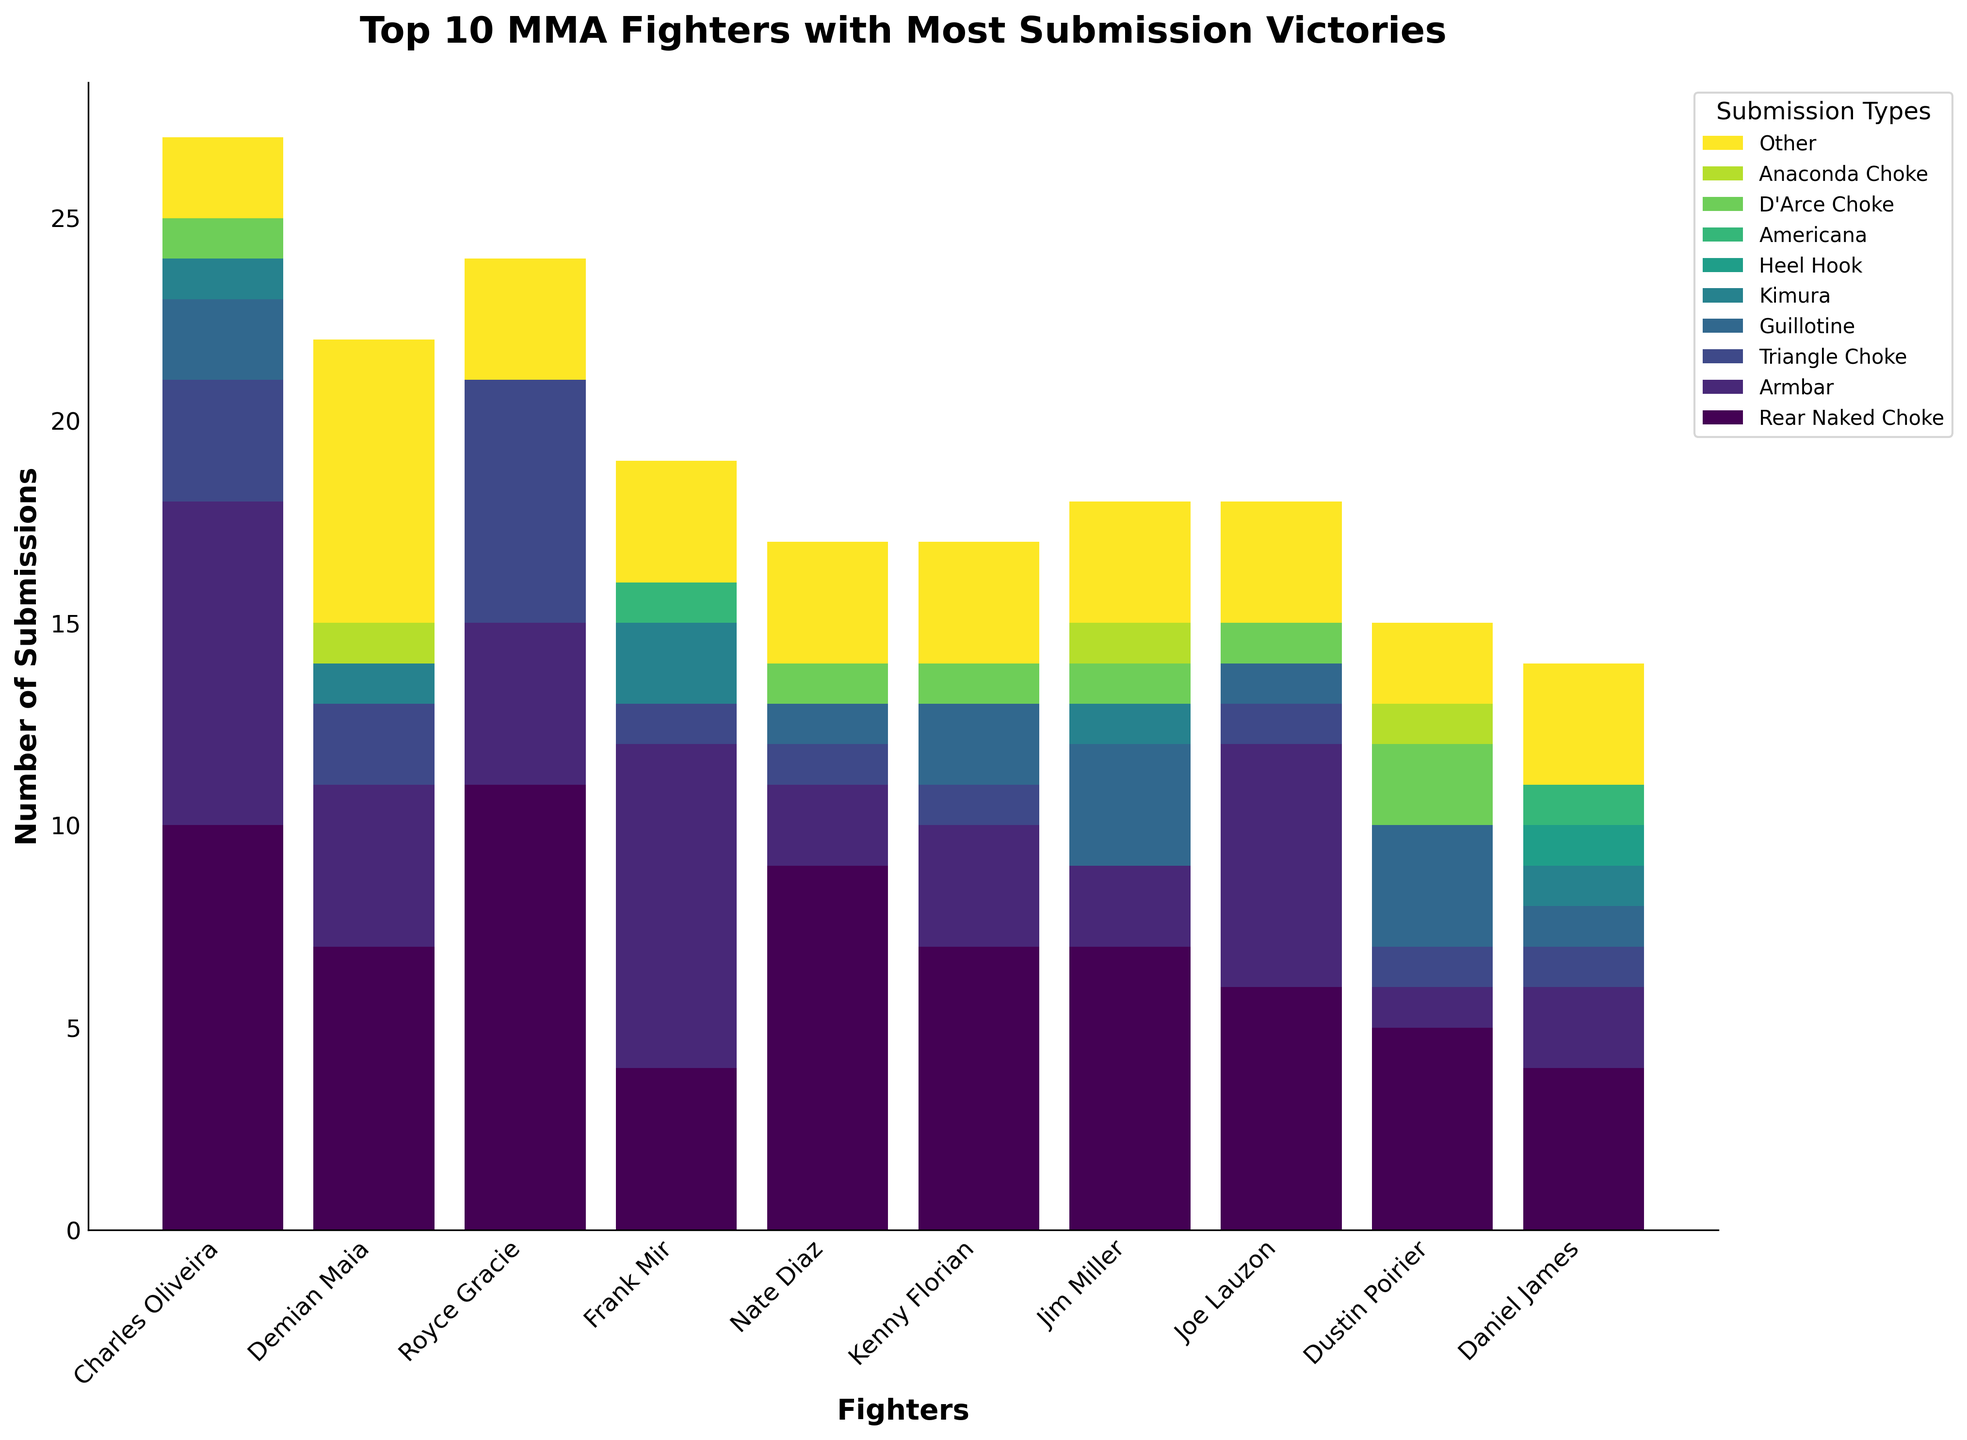Which fighter has the highest number of Rear Naked Chokes? Look for the tallest bar segment colored in the shade representing "Rear Naked Choke." Charles Oliveira's bar is the highest with 10 Rear Naked Chokes.
Answer: Charles Oliveira Who has more Armbar submissions, Frank Mir or Joe Lauzon? Compare the height of the bar segments corresponding to "Armbar" for Frank Mir and Joe Lauzon. Frank Mir has 8 Armbar submissions, and Joe Lauzon has 6.
Answer: Frank Mir How many total Guillotine submissions are there among the top 10 fighters? Add the Guillotine submission counts for all 10 fighters: 2+0+0+0+1+2+3+1+3+1=13.
Answer: 13 Who has the highest number of total submissions and how many? Sum the heights of all the bar segments for each fighter; Royce Gracie has the highest total submissions with a sum of all segments equaling 24.
Answer: Royce Gracie, 24 What is the most common submission type used by Daniel James? Compare the heights of the bar segments for Daniel James; the highest bars are for Rear Naked Choke, Armbar, Heel Hook, and Other, which all have a count of 3 each.
Answer: Rear Naked Choke, Armbar, Heel Hook, Other Which submission type is used more frequently by Nate Diaz than by Charles Oliveira? Compare the bar segments for all submission types between Nate Diaz and Charles Oliveira. Nate Diaz has more Guillotine submissions with 1 compared to 2 of Charles Oliveira.
Answer: None How many more Triangle Choke submissions does Royce Gracie have compared to Dustin Poirier? Royce Gracie has 6 Triangle Choke submissions, and Dustin Poirier has 1. Calculate the difference: 6-1=5.
Answer: 5 Who has used an Americana submission and how many times in total? Identify the bar segment representing Americana for each fighter and sum the counts. Frank Mir and Daniel James have used Americana once each, totaling 1+1=2.
Answer: Frank Mir, Daniel James; 2 Which fighter has the least number of varied submission types? Count the unique non-zero bar segments for each fighter. Jim Miller has only used 6 different submission types, which is the least among the top 10.
Answer: Jim Miller What is the total number of submissions by fighters in the dataset? Sum all the bar heights for all fighters: 10+8+3+2+1+0+0+1+0+2 + 7+4+2+0+1+0+0+0+1+7 + 11+4+6+0+0+0+0+0+0+3 + 4+8+1+0+2+0+1+0+0+3 + 9+2+1+1+0+0+0+1+0+3 + 7+3+1+2+0+0+0+1+0+3 + 7+2+0+3+1+0+0+1+1+3 + 6+6+1+1+0+0+0+1+0+3 + 5+1+1+3+0+0+0+2+1+2 + 4+2+1+1+1+1+1+0+0+3 = 141.
Answer: 141 